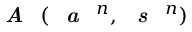<formula> <loc_0><loc_0><loc_500><loc_500>A ( a ^ { n } , s ^ { n } )</formula> 